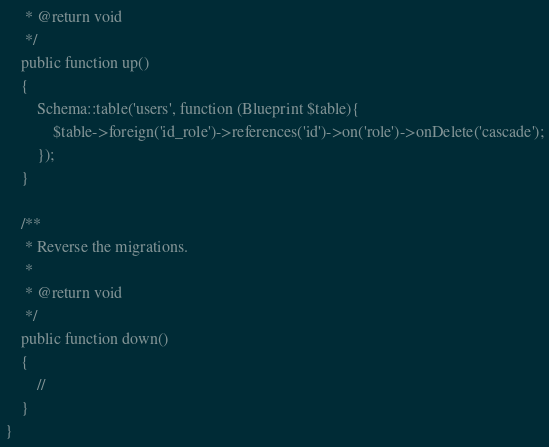<code> <loc_0><loc_0><loc_500><loc_500><_PHP_>     * @return void
     */
    public function up()
    {
        Schema::table('users', function (Blueprint $table){
            $table->foreign('id_role')->references('id')->on('role')->onDelete('cascade');
        });
    }

    /**
     * Reverse the migrations.
     *
     * @return void
     */
    public function down()
    {
        //
    }
}
</code> 